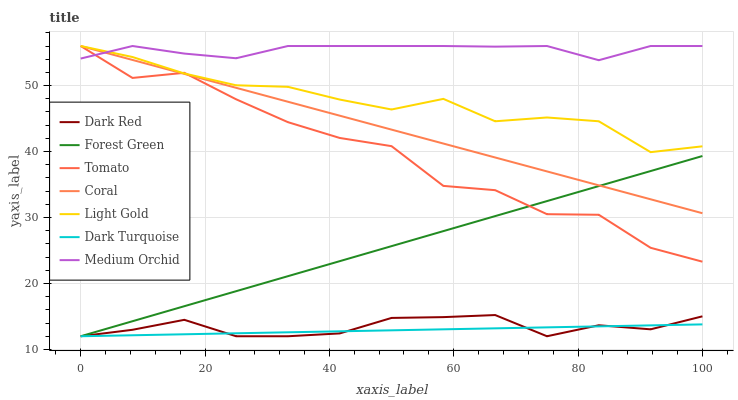Does Dark Turquoise have the minimum area under the curve?
Answer yes or no. Yes. Does Medium Orchid have the maximum area under the curve?
Answer yes or no. Yes. Does Dark Red have the minimum area under the curve?
Answer yes or no. No. Does Dark Red have the maximum area under the curve?
Answer yes or no. No. Is Dark Turquoise the smoothest?
Answer yes or no. Yes. Is Tomato the roughest?
Answer yes or no. Yes. Is Dark Red the smoothest?
Answer yes or no. No. Is Dark Red the roughest?
Answer yes or no. No. Does Dark Red have the lowest value?
Answer yes or no. Yes. Does Coral have the lowest value?
Answer yes or no. No. Does Light Gold have the highest value?
Answer yes or no. Yes. Does Dark Red have the highest value?
Answer yes or no. No. Is Dark Turquoise less than Tomato?
Answer yes or no. Yes. Is Light Gold greater than Forest Green?
Answer yes or no. Yes. Does Medium Orchid intersect Tomato?
Answer yes or no. Yes. Is Medium Orchid less than Tomato?
Answer yes or no. No. Is Medium Orchid greater than Tomato?
Answer yes or no. No. Does Dark Turquoise intersect Tomato?
Answer yes or no. No. 